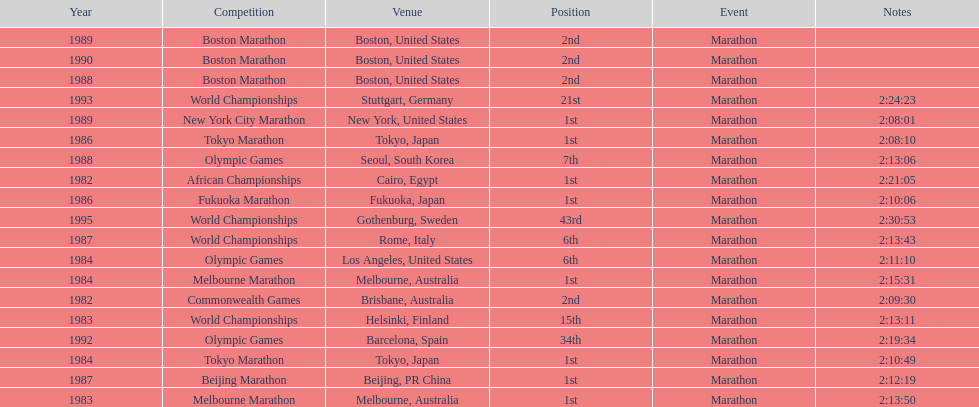How many times in total did ikangaa run the marathon in the olympic games? 3. 